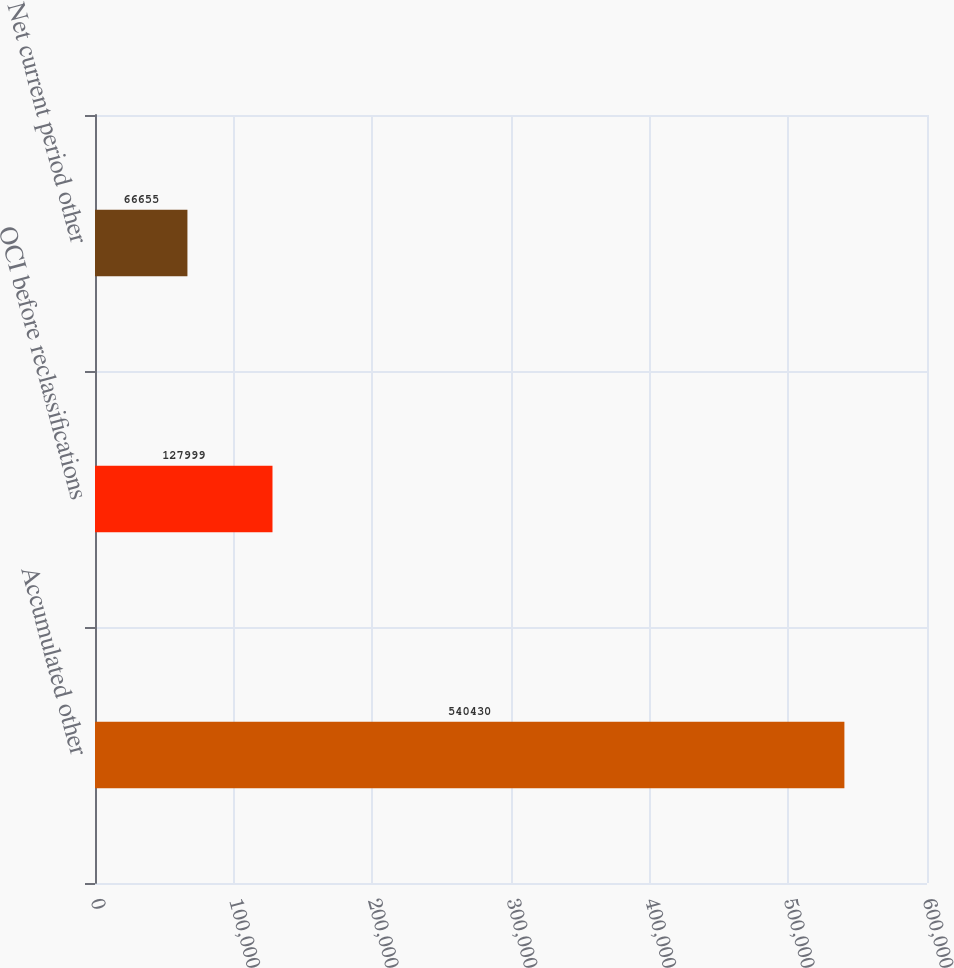<chart> <loc_0><loc_0><loc_500><loc_500><bar_chart><fcel>Accumulated other<fcel>OCI before reclassifications<fcel>Net current period other<nl><fcel>540430<fcel>127999<fcel>66655<nl></chart> 